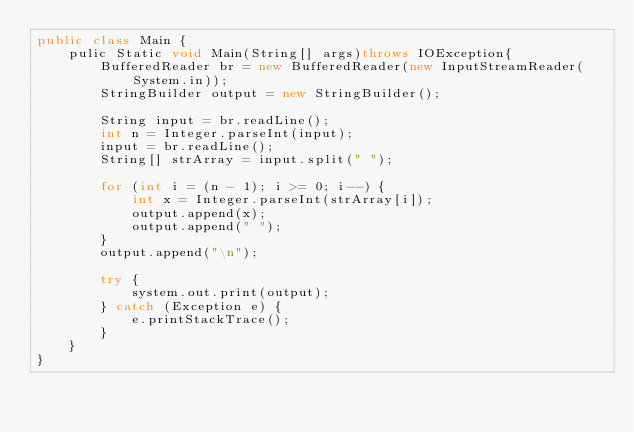Convert code to text. <code><loc_0><loc_0><loc_500><loc_500><_Java_>public class Main {
    pulic Static void Main(String[] args)throws IOException{
        BufferedReader br = new BufferedReader(new InputStreamReader(System.in));
        StringBuilder output = new StringBuilder();

        String input = br.readLine();
        int n = Integer.parseInt(input);
        input = br.readLine();
        String[] strArray = input.split(" ");

        for (int i = (n - 1); i >= 0; i--) {
            int x = Integer.parseInt(strArray[i]);
            output.append(x);
            output.append(" ");
        }
        output.append("\n");

        try {
            system.out.print(output);
        } catch (Exception e) {
            e.printStackTrace();
        }
    }
}</code> 